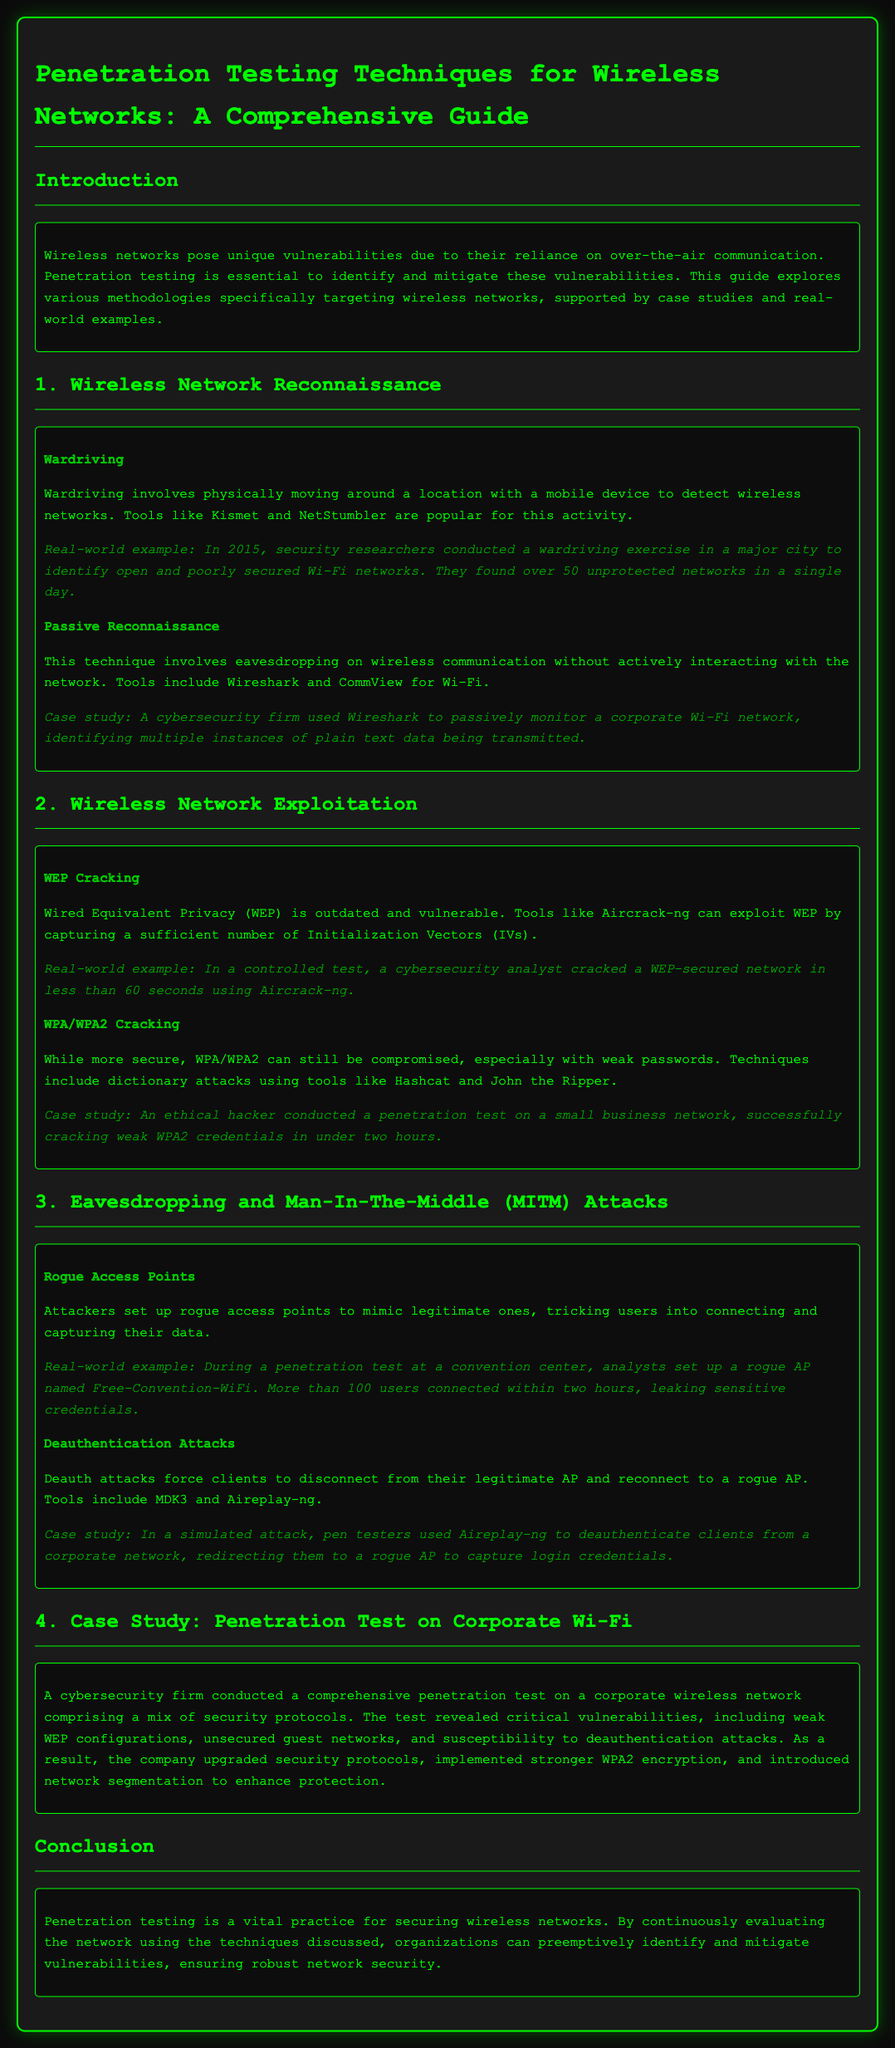What is the purpose of penetration testing in wireless networks? The document states that penetration testing is essential to identify and mitigate vulnerabilities in wireless networks.
Answer: Identify and mitigate vulnerabilities What tool is commonly used for wardriving? The document mentions Kismet and NetStumbler as popular tools for wardriving.
Answer: Kismet and NetStumbler What security protocol is described as outdated and vulnerable? The document refers to Wired Equivalent Privacy (WEP) as outdated and vulnerable.
Answer: WEP How long did it take to crack a WEP-secured network in the real-world example? The document states that a cybersecurity analyst cracked a WEP-secured network in less than 60 seconds.
Answer: Less than 60 seconds What technique is used to force clients to connect to a rogue access point? The document describes deauthentication attacks as a technique to force clients to connect to a rogue access point.
Answer: Deauthentication attacks In the case study, what type of vulnerabilities were revealed during the penetration test on a corporate network? The vulnerabilities revealed included weak WEP configurations, unsecured guest networks, and susceptibility to deauthentication attacks.
Answer: Weak WEP configurations, unsecured guest networks, and susceptibility to deauthentication attacks What type of attack involves setting up rogue access points? The document describes rogue access points as a method used in eavesdropping and Man-In-The-Middle attacks.
Answer: Rogue access points What was the outcome of the cybersecurity firm’s penetration test on the corporate wireless network? The company upgraded security protocols, implemented stronger WPA2 encryption, and introduced network segmentation.
Answer: Upgraded security protocols, implemented stronger WPA2 encryption, and introduced network segmentation 